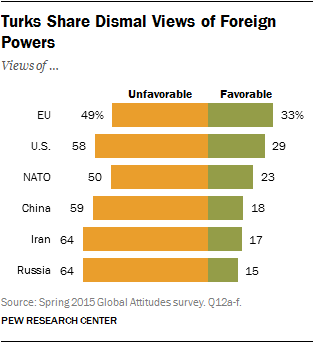Point out several critical features in this image. According to a recent survey, 59% of the respondents in China had unfavorable views towards a particular topic. The value of the first two orange bars from the bottom is equal. 